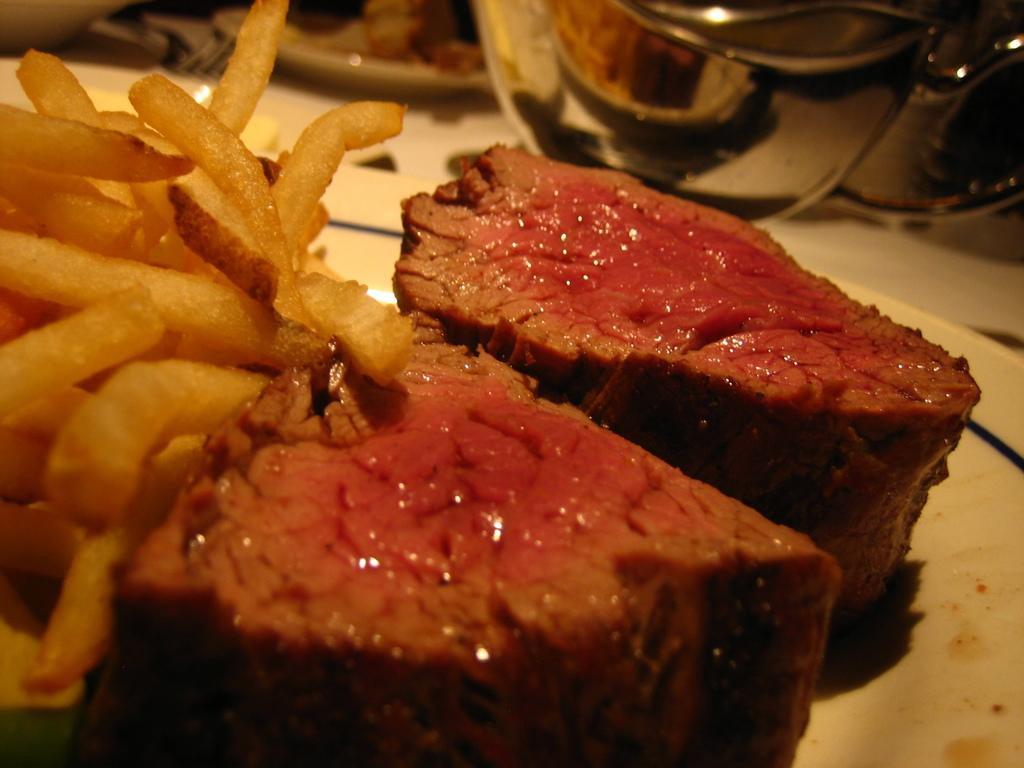What is on the plate in the image? There is a white plate in the image, with french fries and meat on it. What is located above the plate in the image? There is a bowl at the top of the plate. How does the plate help the minister sleep better in the image? There is no mention of a minister or sleeping in the image; the image only shows a plate with french fries and meat, and a bowl above it. 